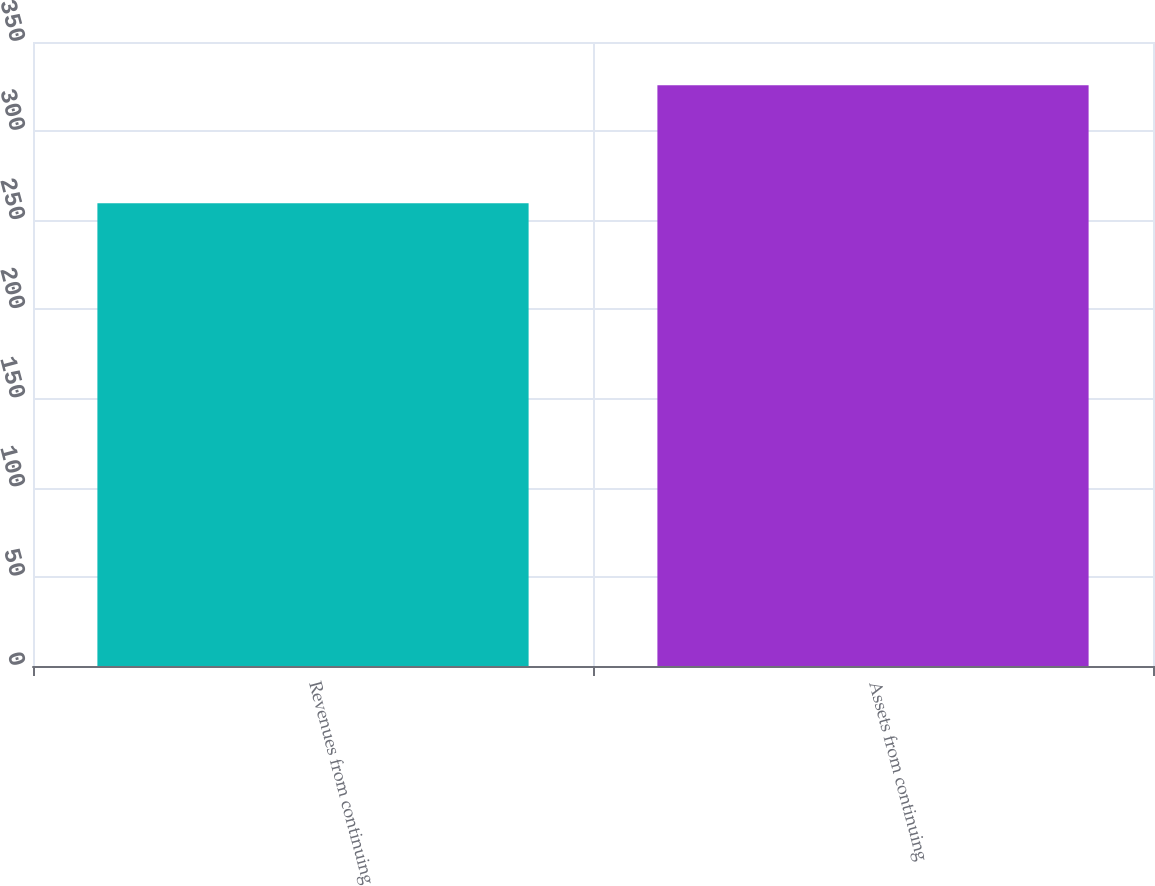Convert chart. <chart><loc_0><loc_0><loc_500><loc_500><bar_chart><fcel>Revenues from continuing<fcel>Assets from continuing<nl><fcel>259.5<fcel>325.8<nl></chart> 